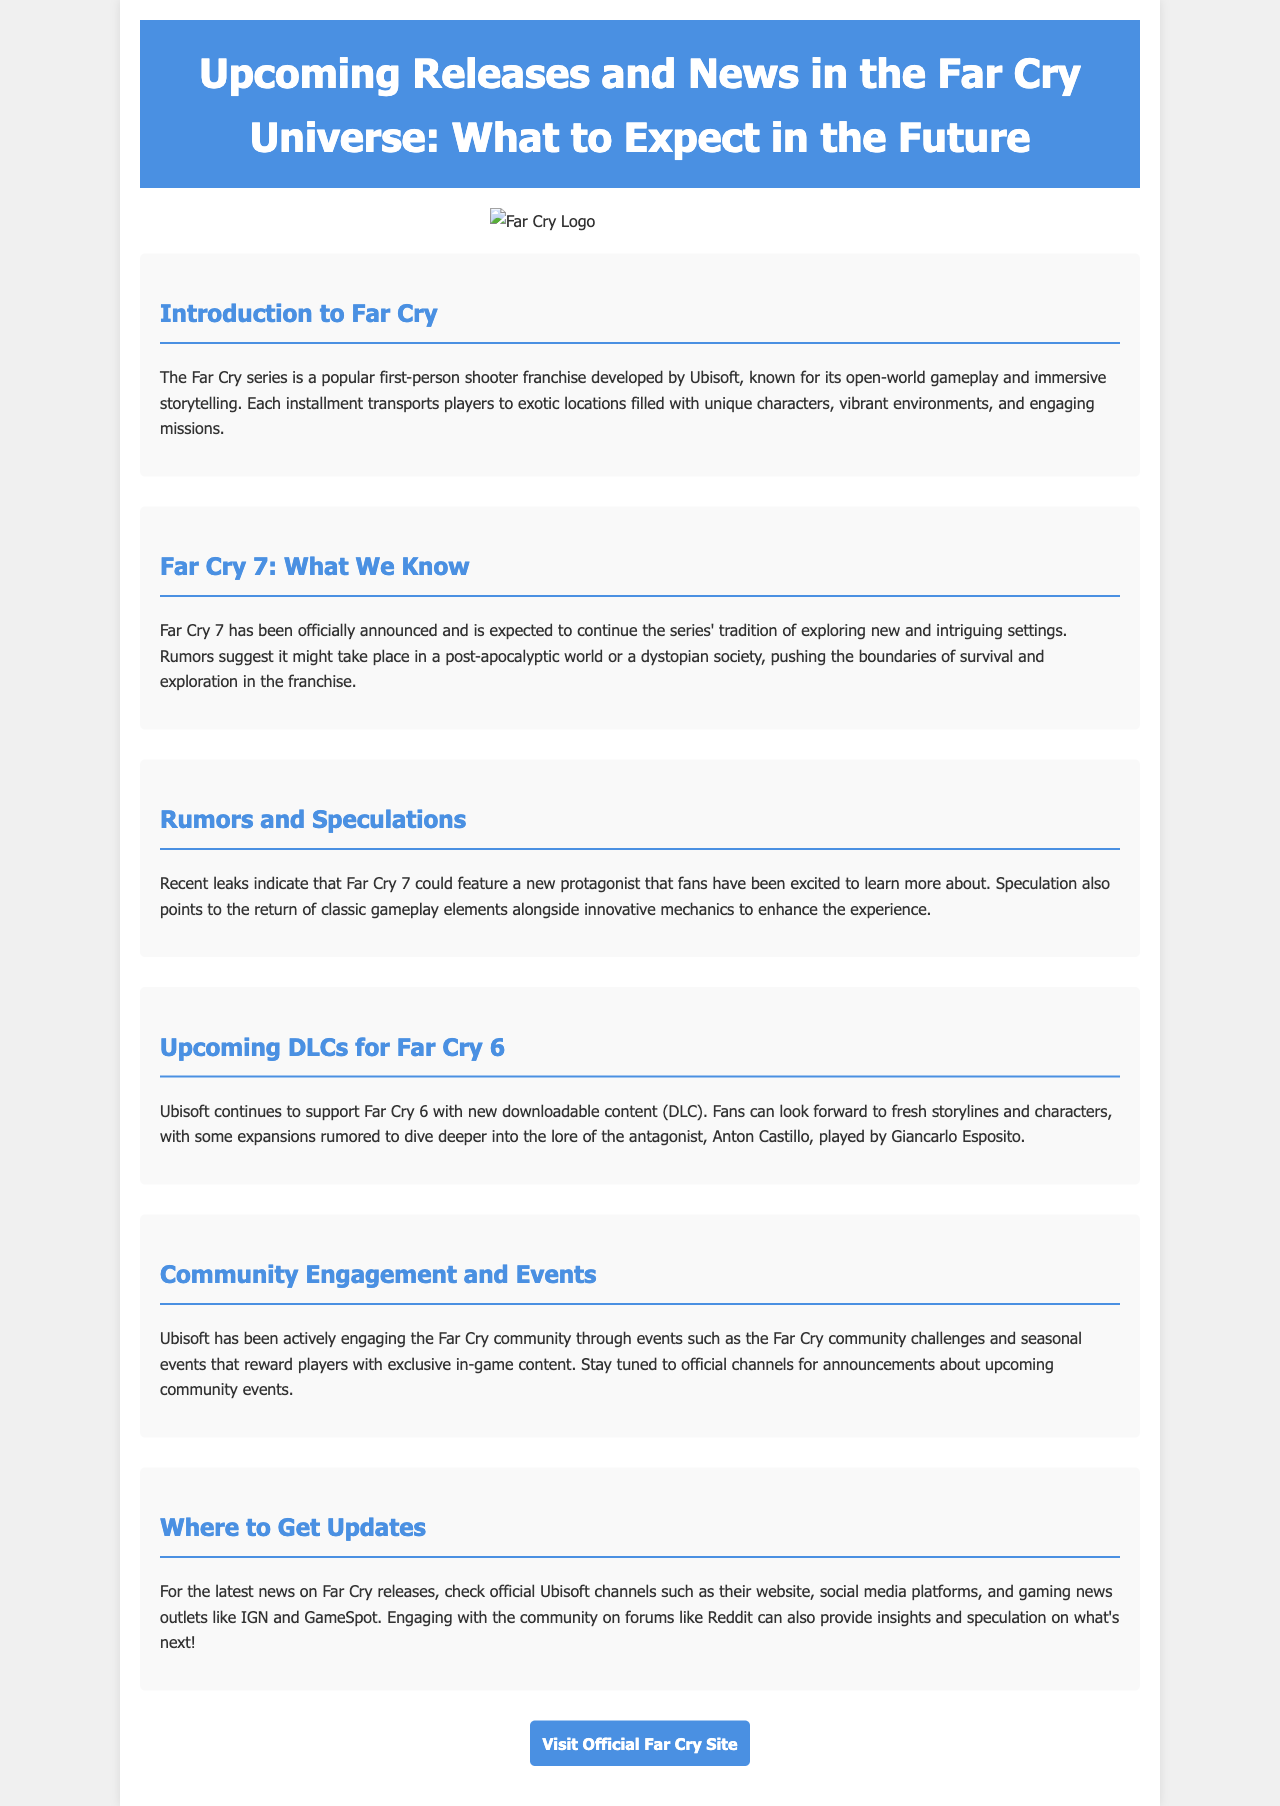What is the latest installment in the Far Cry series? The document states that Far Cry 7 has been officially announced, which is the upcoming title in the series.
Answer: Far Cry 7 What is the setting of Far Cry 7 rumored to be? The document mentions that rumors suggest Far Cry 7 might take place in a post-apocalyptic world or a dystopian society.
Answer: Post-apocalyptic world or dystopian society Who is the antagonist in Far Cry 6? According to the document, Anton Castillo, played by Giancarlo Esposito, is the antagonist in Far Cry 6.
Answer: Anton Castillo What type of content is being released for Far Cry 6? The section discusses upcoming downloadable content (DLC) as part of the support for Far Cry 6.
Answer: Downloadable content (DLC) Where can players find updates about Far Cry releases? The document advises that the latest news can be found on official Ubisoft channels such as their website and social media platforms.
Answer: Official Ubisoft channels What does the community engage in to earn in-game content? The document describes community challenges and seasonal events that reward players with exclusive in-game content.
Answer: Community challenges and seasonal events What major feature is Far Cry known for? The document highlights the open-world gameplay as a key feature of the Far Cry series.
Answer: Open-world gameplay What element from previous games might return in Far Cry 7? The document speculates that classic gameplay elements could return alongside innovative mechanics in Far Cry 7.
Answer: Classic gameplay elements What type of game is Far Cry classified as? The document categorizes Far Cry as a popular first-person shooter franchise.
Answer: First-person shooter 